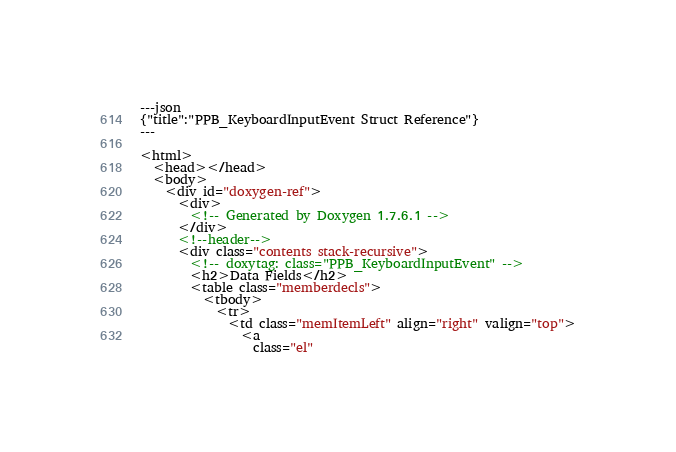Convert code to text. <code><loc_0><loc_0><loc_500><loc_500><_HTML_>---json
{"title":"PPB_KeyboardInputEvent Struct Reference"}
---

<html>
  <head></head>
  <body>
    <div id="doxygen-ref">
      <div>
        <!-- Generated by Doxygen 1.7.6.1 -->
      </div>
      <!--header-->
      <div class="contents stack-recursive">
        <!-- doxytag: class="PPB_KeyboardInputEvent" -->
        <h2>Data Fields</h2>
        <table class="memberdecls">
          <tbody>
            <tr>
              <td class="memItemLeft" align="right" valign="top">
                <a
                  class="el"</code> 